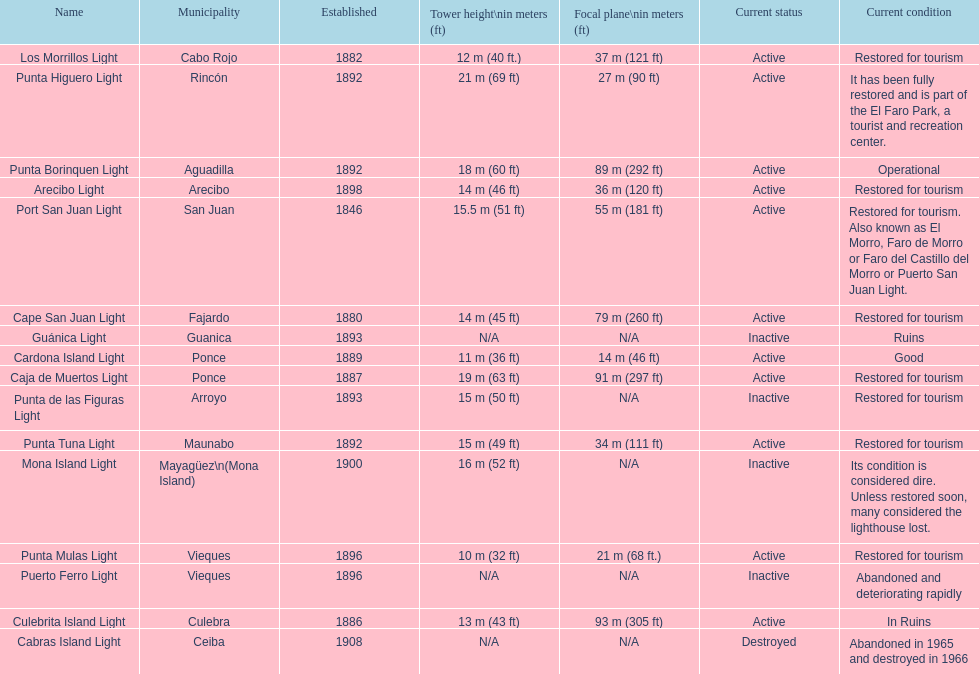What is the largest tower Punta Higuero Light. 